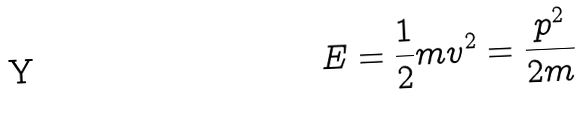Convert formula to latex. <formula><loc_0><loc_0><loc_500><loc_500>E = \frac { 1 } { 2 } m v ^ { 2 } = \frac { p ^ { 2 } } { 2 m }</formula> 